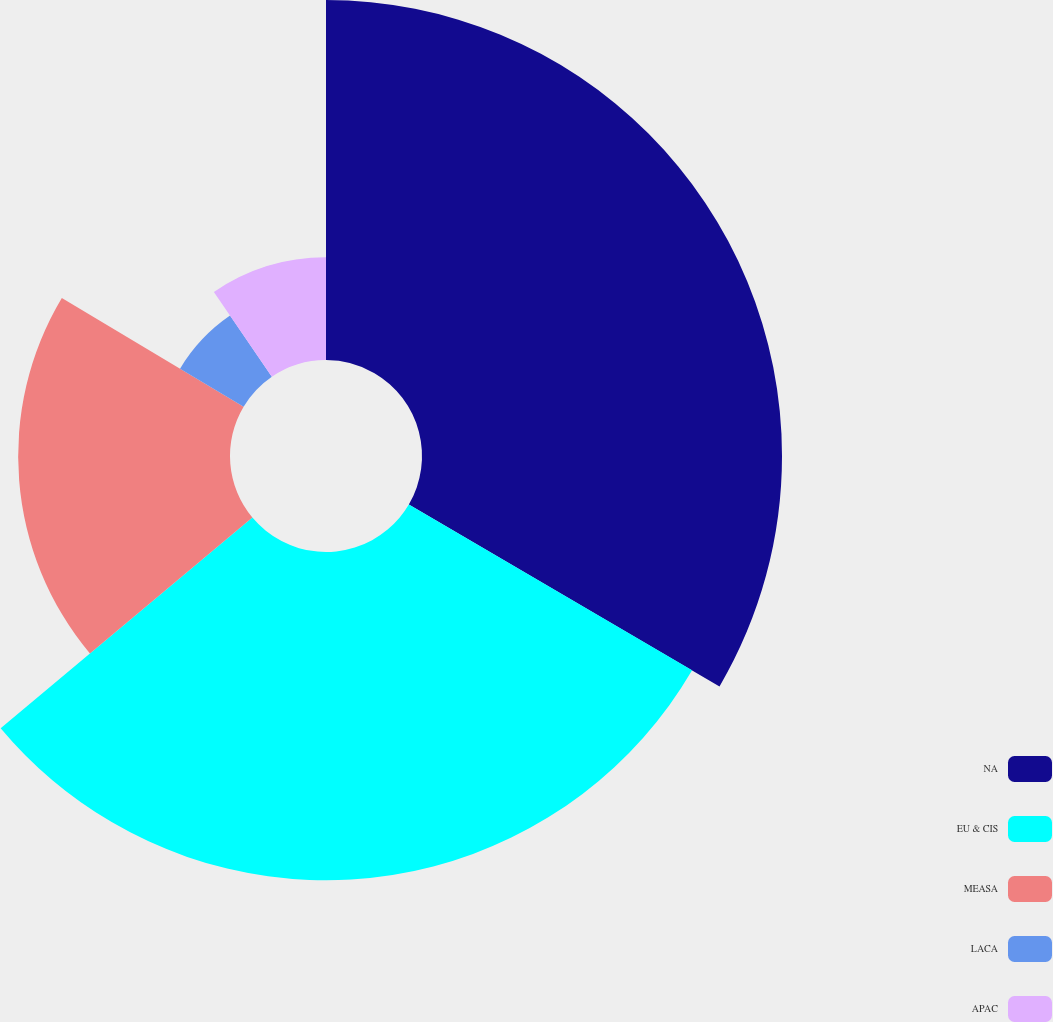Convert chart. <chart><loc_0><loc_0><loc_500><loc_500><pie_chart><fcel>NA<fcel>EU & CIS<fcel>MEASA<fcel>LACA<fcel>APAC<nl><fcel>33.43%<fcel>30.48%<fcel>19.67%<fcel>6.88%<fcel>9.54%<nl></chart> 